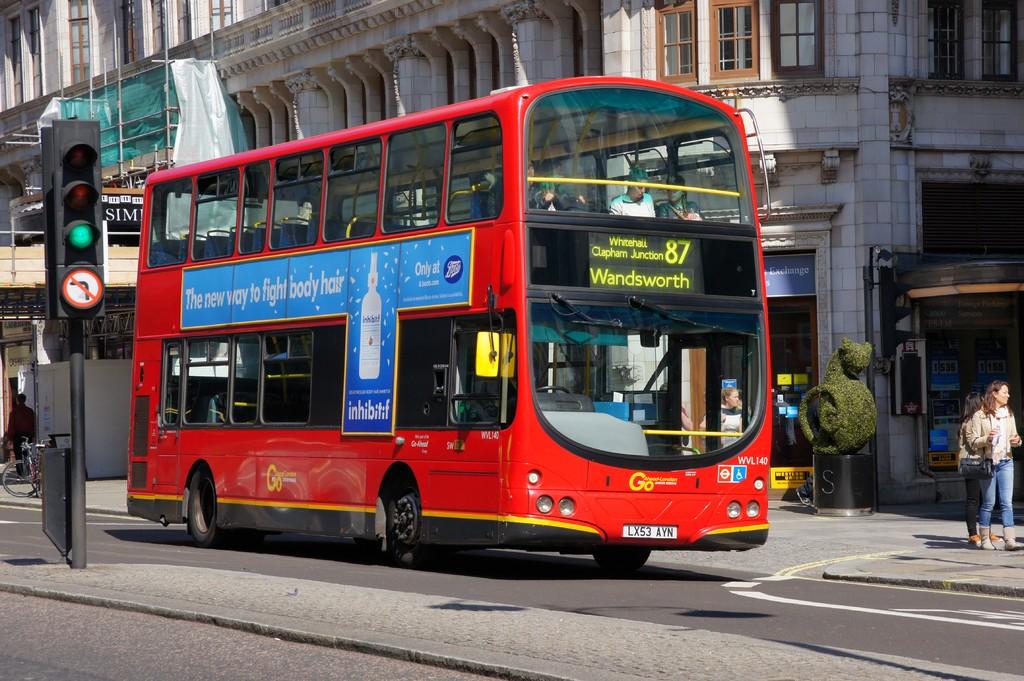What color is the number 87 on the bus?
Give a very brief answer. Yellow. 